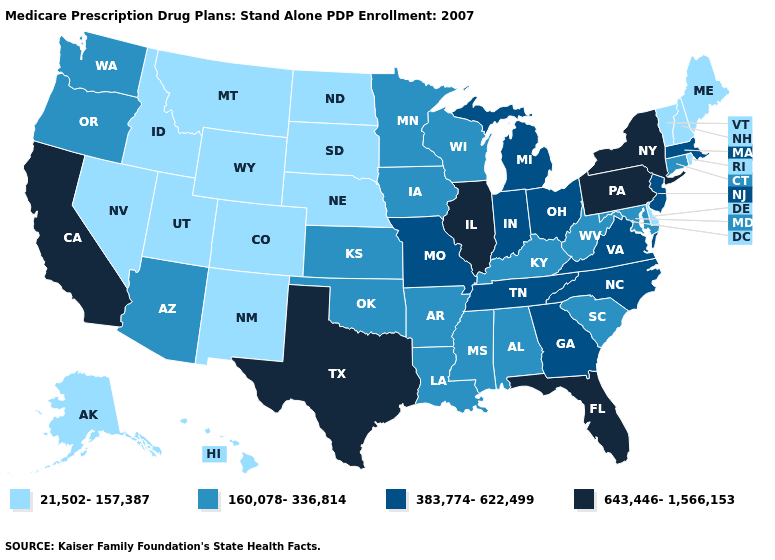What is the value of Nebraska?
Write a very short answer. 21,502-157,387. Among the states that border Mississippi , which have the lowest value?
Quick response, please. Alabama, Arkansas, Louisiana. Name the states that have a value in the range 383,774-622,499?
Answer briefly. Georgia, Indiana, Massachusetts, Michigan, Missouri, North Carolina, New Jersey, Ohio, Tennessee, Virginia. What is the value of New York?
Give a very brief answer. 643,446-1,566,153. Which states have the highest value in the USA?
Concise answer only. California, Florida, Illinois, New York, Pennsylvania, Texas. Among the states that border California , which have the highest value?
Short answer required. Arizona, Oregon. Which states hav the highest value in the South?
Quick response, please. Florida, Texas. Name the states that have a value in the range 383,774-622,499?
Give a very brief answer. Georgia, Indiana, Massachusetts, Michigan, Missouri, North Carolina, New Jersey, Ohio, Tennessee, Virginia. Name the states that have a value in the range 383,774-622,499?
Write a very short answer. Georgia, Indiana, Massachusetts, Michigan, Missouri, North Carolina, New Jersey, Ohio, Tennessee, Virginia. What is the lowest value in the MidWest?
Quick response, please. 21,502-157,387. Among the states that border Delaware , which have the highest value?
Give a very brief answer. Pennsylvania. What is the highest value in the MidWest ?
Quick response, please. 643,446-1,566,153. What is the highest value in the USA?
Write a very short answer. 643,446-1,566,153. 